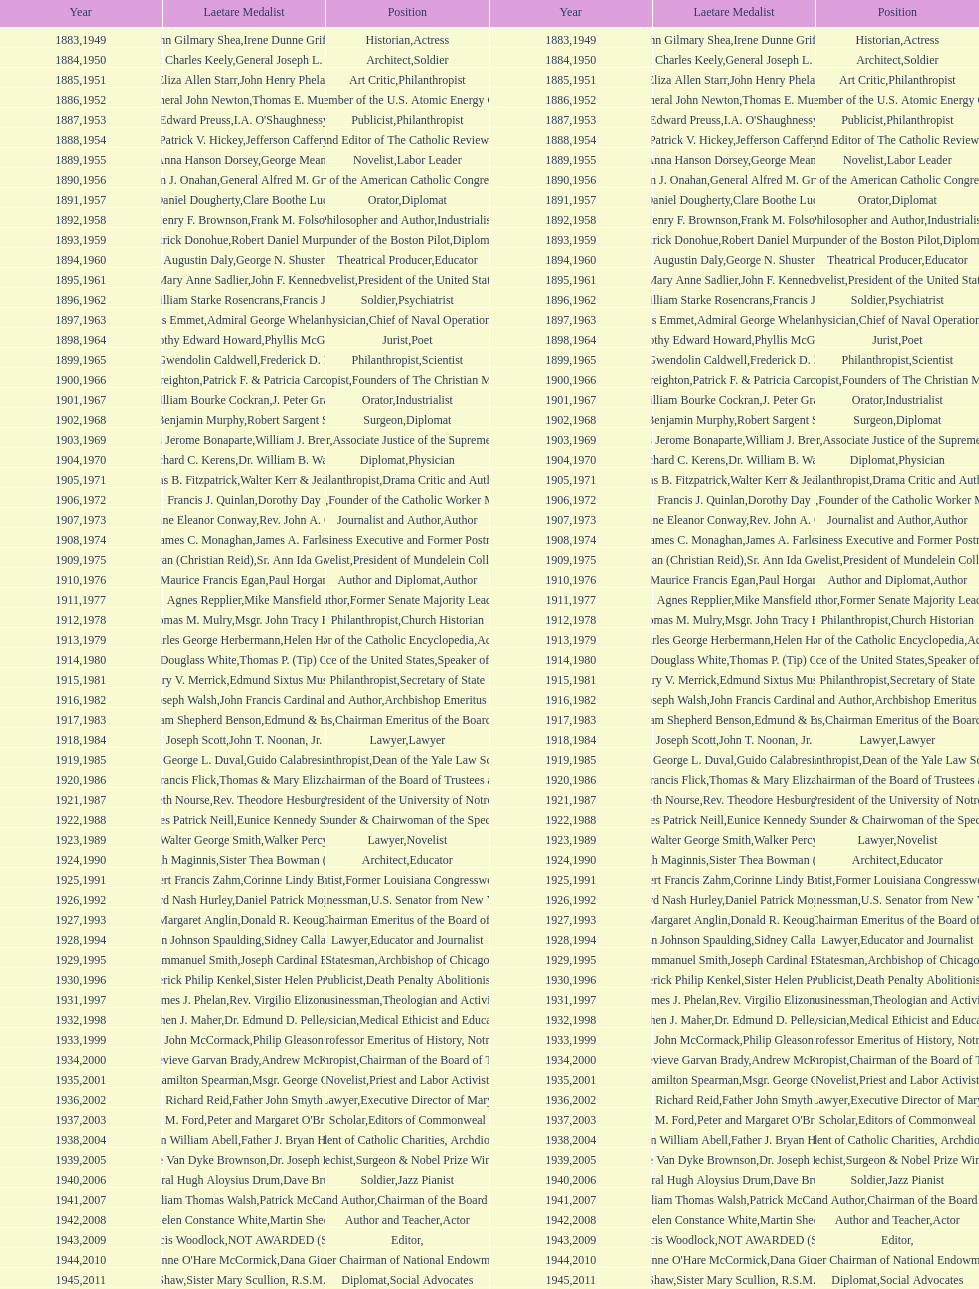Who won the medal after thomas e. murray in 1952? I.A. O'Shaughnessy. 